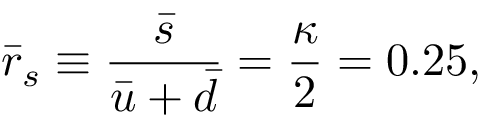<formula> <loc_0><loc_0><loc_500><loc_500>\bar { r } _ { s } \equiv \frac { \bar { s } } { \bar { u } + \bar { d } } = \frac { \kappa } { 2 } = 0 . 2 5 ,</formula> 